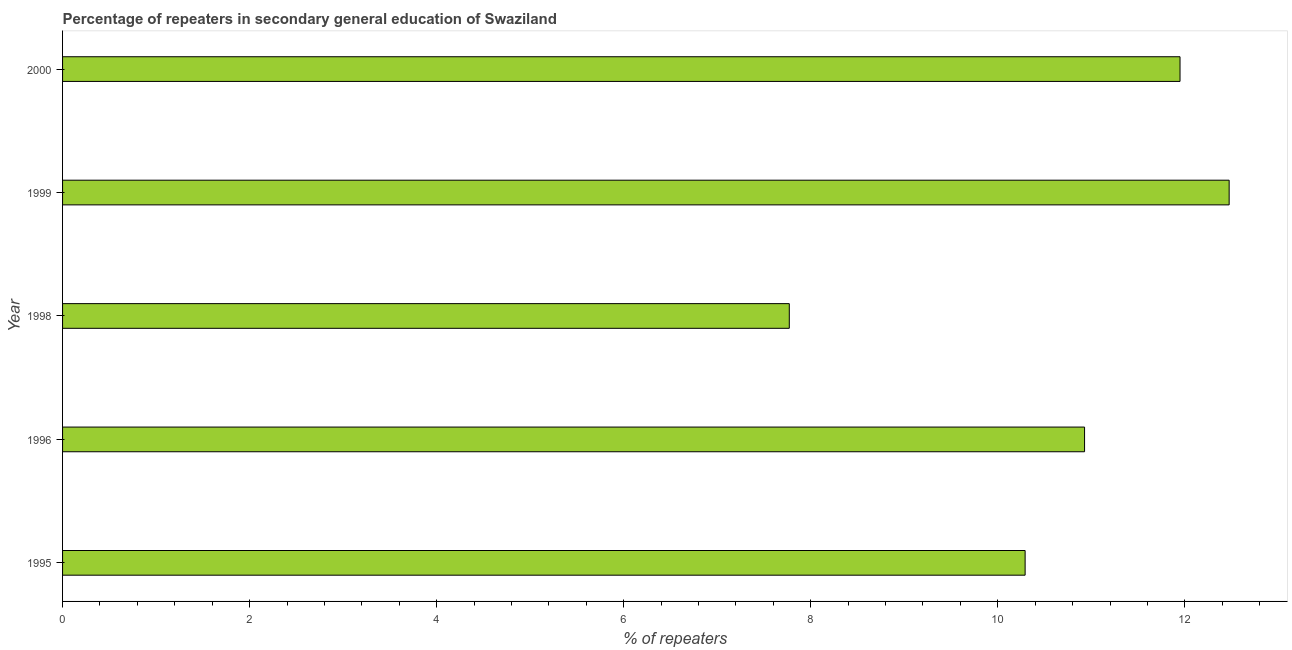Does the graph contain any zero values?
Keep it short and to the point. No. What is the title of the graph?
Your answer should be very brief. Percentage of repeaters in secondary general education of Swaziland. What is the label or title of the X-axis?
Give a very brief answer. % of repeaters. What is the label or title of the Y-axis?
Your answer should be very brief. Year. What is the percentage of repeaters in 1998?
Provide a short and direct response. 7.77. Across all years, what is the maximum percentage of repeaters?
Give a very brief answer. 12.47. Across all years, what is the minimum percentage of repeaters?
Make the answer very short. 7.77. In which year was the percentage of repeaters maximum?
Your answer should be compact. 1999. What is the sum of the percentage of repeaters?
Your answer should be very brief. 53.41. What is the difference between the percentage of repeaters in 1995 and 1998?
Keep it short and to the point. 2.52. What is the average percentage of repeaters per year?
Your answer should be very brief. 10.68. What is the median percentage of repeaters?
Your response must be concise. 10.93. What is the ratio of the percentage of repeaters in 1999 to that in 2000?
Make the answer very short. 1.04. Is the percentage of repeaters in 1998 less than that in 2000?
Your response must be concise. Yes. Is the difference between the percentage of repeaters in 1995 and 2000 greater than the difference between any two years?
Make the answer very short. No. What is the difference between the highest and the second highest percentage of repeaters?
Your answer should be compact. 0.53. In how many years, is the percentage of repeaters greater than the average percentage of repeaters taken over all years?
Your response must be concise. 3. How many bars are there?
Provide a short and direct response. 5. What is the % of repeaters in 1995?
Offer a very short reply. 10.29. What is the % of repeaters in 1996?
Provide a short and direct response. 10.93. What is the % of repeaters of 1998?
Keep it short and to the point. 7.77. What is the % of repeaters of 1999?
Keep it short and to the point. 12.47. What is the % of repeaters in 2000?
Give a very brief answer. 11.95. What is the difference between the % of repeaters in 1995 and 1996?
Your answer should be compact. -0.64. What is the difference between the % of repeaters in 1995 and 1998?
Your answer should be very brief. 2.52. What is the difference between the % of repeaters in 1995 and 1999?
Ensure brevity in your answer.  -2.18. What is the difference between the % of repeaters in 1995 and 2000?
Provide a short and direct response. -1.66. What is the difference between the % of repeaters in 1996 and 1998?
Your response must be concise. 3.16. What is the difference between the % of repeaters in 1996 and 1999?
Offer a very short reply. -1.55. What is the difference between the % of repeaters in 1996 and 2000?
Provide a succinct answer. -1.02. What is the difference between the % of repeaters in 1998 and 1999?
Your response must be concise. -4.7. What is the difference between the % of repeaters in 1998 and 2000?
Your answer should be very brief. -4.18. What is the difference between the % of repeaters in 1999 and 2000?
Give a very brief answer. 0.53. What is the ratio of the % of repeaters in 1995 to that in 1996?
Your answer should be very brief. 0.94. What is the ratio of the % of repeaters in 1995 to that in 1998?
Your response must be concise. 1.32. What is the ratio of the % of repeaters in 1995 to that in 1999?
Give a very brief answer. 0.82. What is the ratio of the % of repeaters in 1995 to that in 2000?
Provide a succinct answer. 0.86. What is the ratio of the % of repeaters in 1996 to that in 1998?
Offer a terse response. 1.41. What is the ratio of the % of repeaters in 1996 to that in 1999?
Offer a very short reply. 0.88. What is the ratio of the % of repeaters in 1996 to that in 2000?
Make the answer very short. 0.92. What is the ratio of the % of repeaters in 1998 to that in 1999?
Your answer should be very brief. 0.62. What is the ratio of the % of repeaters in 1998 to that in 2000?
Your response must be concise. 0.65. What is the ratio of the % of repeaters in 1999 to that in 2000?
Ensure brevity in your answer.  1.04. 